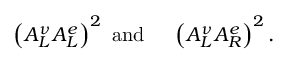Convert formula to latex. <formula><loc_0><loc_0><loc_500><loc_500>\left ( A _ { L } ^ { \nu } A _ { L } ^ { e } \right ) ^ { 2 } a n d \left ( A _ { L } ^ { \nu } A _ { R } ^ { e } \right ) ^ { 2 } .</formula> 